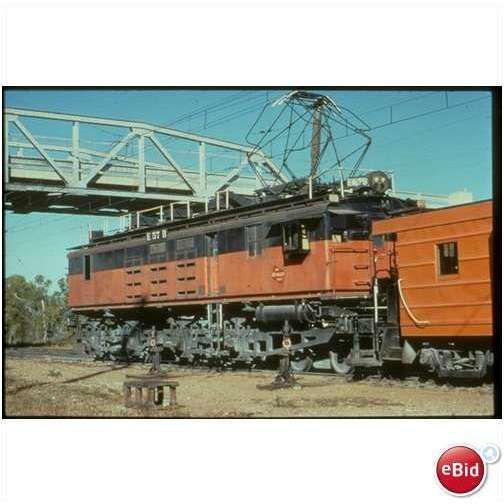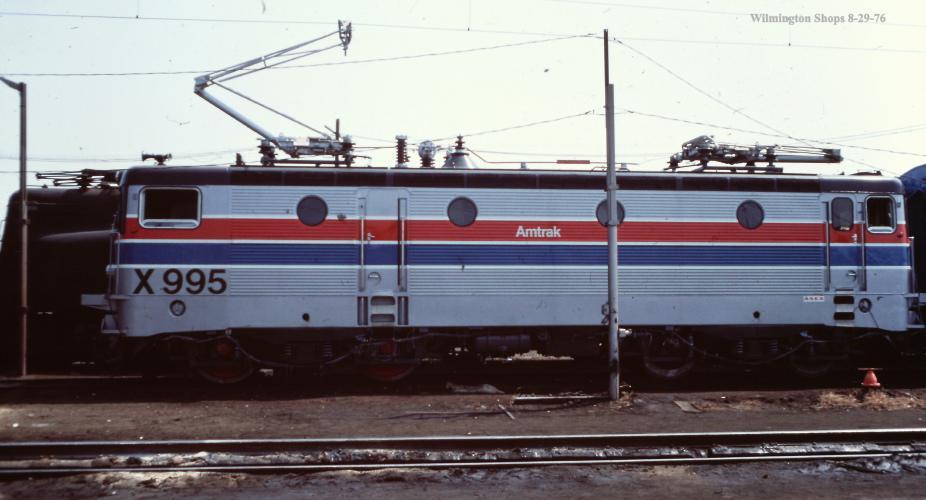The first image is the image on the left, the second image is the image on the right. Analyze the images presented: Is the assertion "An image shows a rightward angled orange and black train, with no bridge extending over it." valid? Answer yes or no. No. The first image is the image on the left, the second image is the image on the right. Considering the images on both sides, is "There is a yellow train with red markings in one of the images." valid? Answer yes or no. No. 